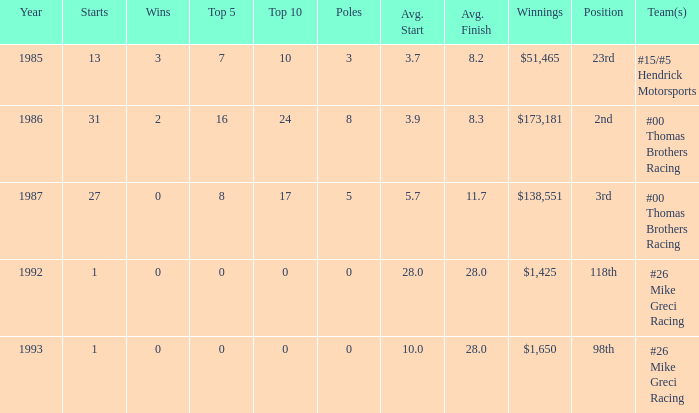What was the average finish the year Bodine finished 3rd? 11.7. 